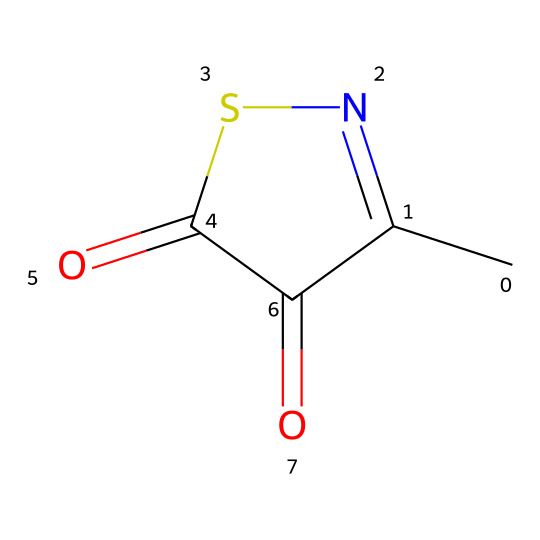What is the molecular formula of methylisothiazolinone? To determine the molecular formula, we analyze the SMILES representation. Counting the carbon (C), nitrogen (N), sulfur (S), and oxygen (O) atoms provides us: 3 carbons, 1 nitrogen, 1 sulfur, and 2 oxygens. Thus, the molecular formula becomes C3H3N1O2S1.
Answer: C3H3N1O2S1 How many rings are present in the structure? By looking at the SMILES, we identify the ring structure marked by the '1' characters. There is one such '1', indicating one ring.
Answer: 1 Which functional group is present in methylisothiazolinone? Analyzing the structure, it becomes evident that there are ketone (=O) groups in the molecule. The presence of two carbonyl groups designates it as having ketone functional groups.
Answer: ketone What role does methylisothiazolinone play in personal care products? Methylisothiazolinone is primarily used as a preservative, inhibiting the growth of bacteria and fungi in formulations. This role is critical in maintaining product safety and integrity.
Answer: preservative What is the total number of oxygen atoms in methylisothiazolinone? Following the analysis of the SMILES string, it shows that there are two 'O' symbols, indicating that there are two oxygen atoms present in the molecule.
Answer: 2 How many hydrogen atoms are present in the structure? To find the number of hydrogen atoms, we look at the formula derived from the SMILES. From the structure analysis, we find that there are three hydrogen atoms indicated by the count associated with the carbon structure.
Answer: 3 Why is methylisothiazolinone considered a preservative? This compound has antimicrobial properties, capable of preventing the growth of microorganisms in water-based products, making it effective for preserving formulations from spoilage.
Answer: antimicrobial 